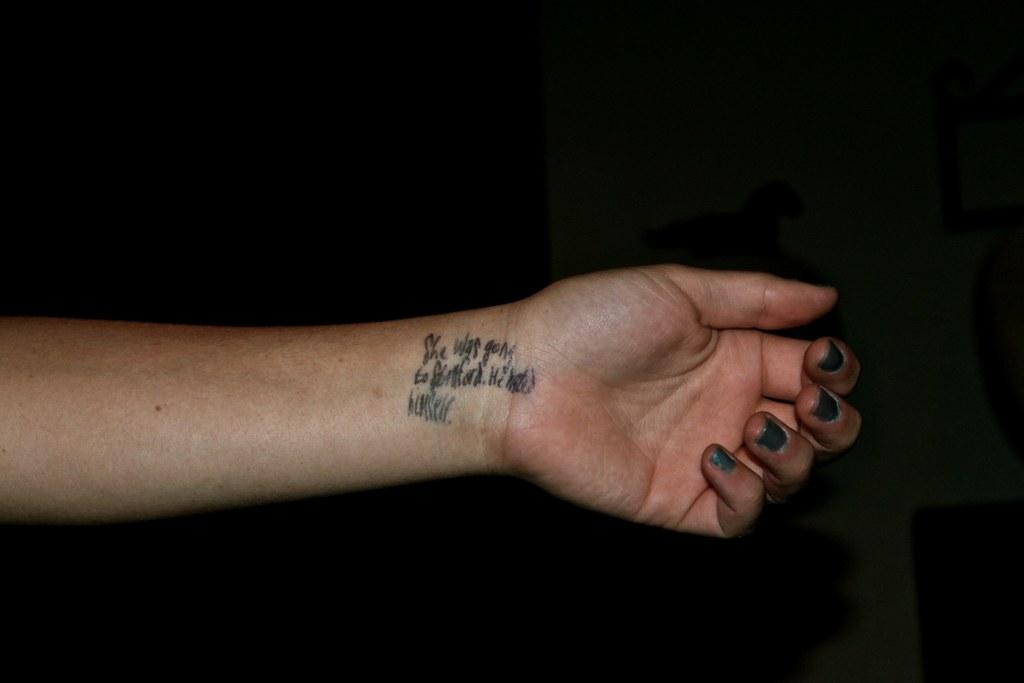What is the main subject of the image? The main subject of the image is a person's hand. What is written or drawn on the hand? There is text on the hand. Can you describe the background of the image? The background of the image is dark. Reasoning: Let'g: Let's think step by step in order to produce the conversation. We start by identifying the main subject of the image, which is the person's hand. Then, we describe the text on the hand, as it is mentioned in the facts. Finally, we mention the background of the image, which is dark. Absurd Question/Answer: What type of plants can be seen growing on the hand in the image? There are no plants visible on the hand in the image. How many chickens are present on the hand in the image? There are no chickens present on the hand in the image. What type of yarn can be seen wrapped around the hand in the image? There is no yarn visible on the hand in the image. 